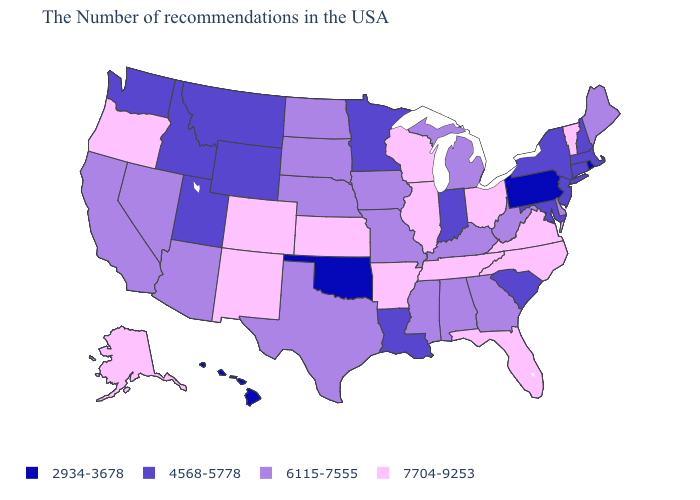What is the value of Connecticut?
Concise answer only. 4568-5778. Among the states that border New Jersey , which have the highest value?
Be succinct. Delaware. Is the legend a continuous bar?
Answer briefly. No. What is the value of South Dakota?
Keep it brief. 6115-7555. What is the lowest value in the USA?
Be succinct. 2934-3678. Does Kansas have the lowest value in the USA?
Give a very brief answer. No. What is the highest value in the USA?
Concise answer only. 7704-9253. Is the legend a continuous bar?
Write a very short answer. No. What is the value of New Jersey?
Keep it brief. 4568-5778. Name the states that have a value in the range 4568-5778?
Give a very brief answer. Massachusetts, New Hampshire, Connecticut, New York, New Jersey, Maryland, South Carolina, Indiana, Louisiana, Minnesota, Wyoming, Utah, Montana, Idaho, Washington. What is the highest value in the South ?
Concise answer only. 7704-9253. Among the states that border Vermont , which have the lowest value?
Answer briefly. Massachusetts, New Hampshire, New York. Which states have the lowest value in the West?
Give a very brief answer. Hawaii. Does Oregon have a higher value than Missouri?
Answer briefly. Yes. 